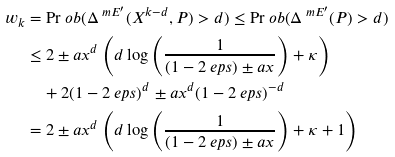<formula> <loc_0><loc_0><loc_500><loc_500>w _ { k } & = \Pr o b ( \Delta ^ { \ m { E } ^ { \prime } } ( X ^ { k - d } , P ) > d ) \leq \Pr o b ( \Delta ^ { \ m { E } ^ { \prime } } ( P ) > d ) \\ & \leq 2 \pm a x ^ { d } \left ( d \log { \left ( \frac { 1 } { ( 1 - 2 \ e p s ) \pm a x } \right ) } + \kappa \right ) \\ & \quad + 2 ( 1 - 2 \ e p s ) ^ { d } \pm a x ^ { d } ( 1 - 2 \ e p s ) ^ { - d } \\ & = 2 \pm a x ^ { d } \left ( d \log { \left ( \frac { 1 } { ( 1 - 2 \ e p s ) \pm a x } \right ) } + \kappa + 1 \right )</formula> 